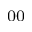Convert formula to latex. <formula><loc_0><loc_0><loc_500><loc_500>_ { 0 0 }</formula> 